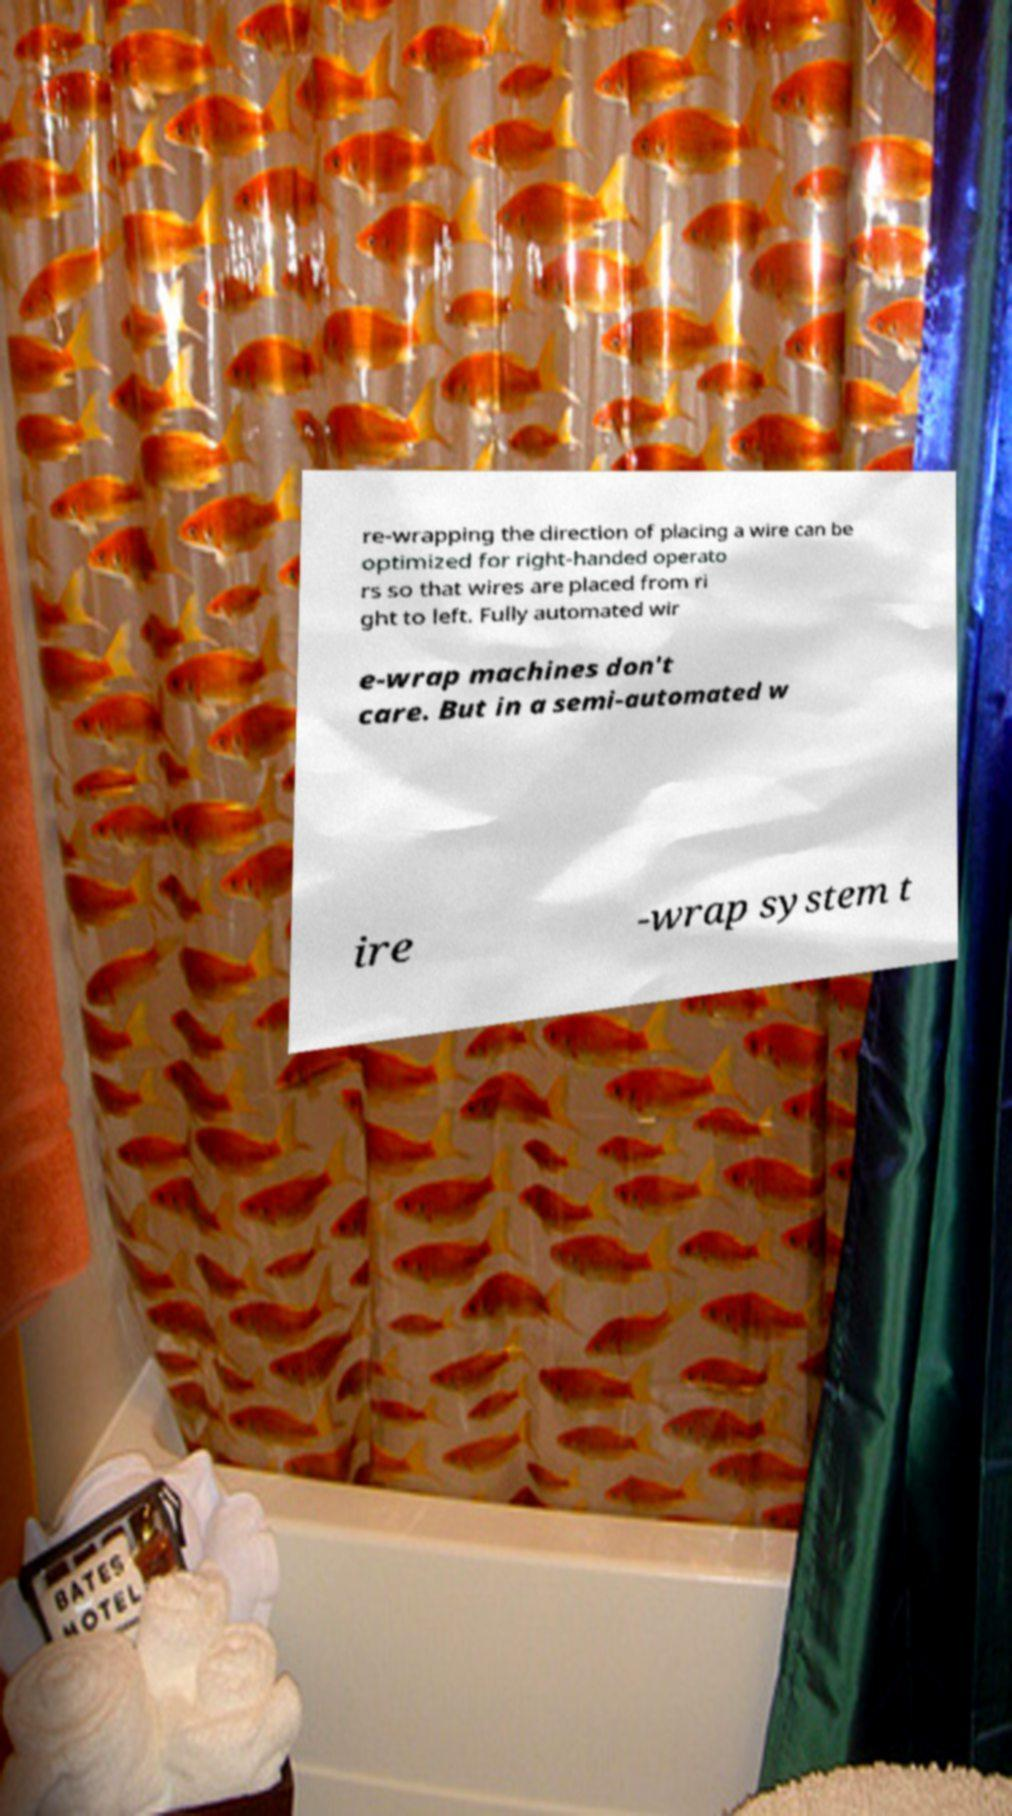Can you read and provide the text displayed in the image?This photo seems to have some interesting text. Can you extract and type it out for me? re-wrapping the direction of placing a wire can be optimized for right-handed operato rs so that wires are placed from ri ght to left. Fully automated wir e-wrap machines don't care. But in a semi-automated w ire -wrap system t 